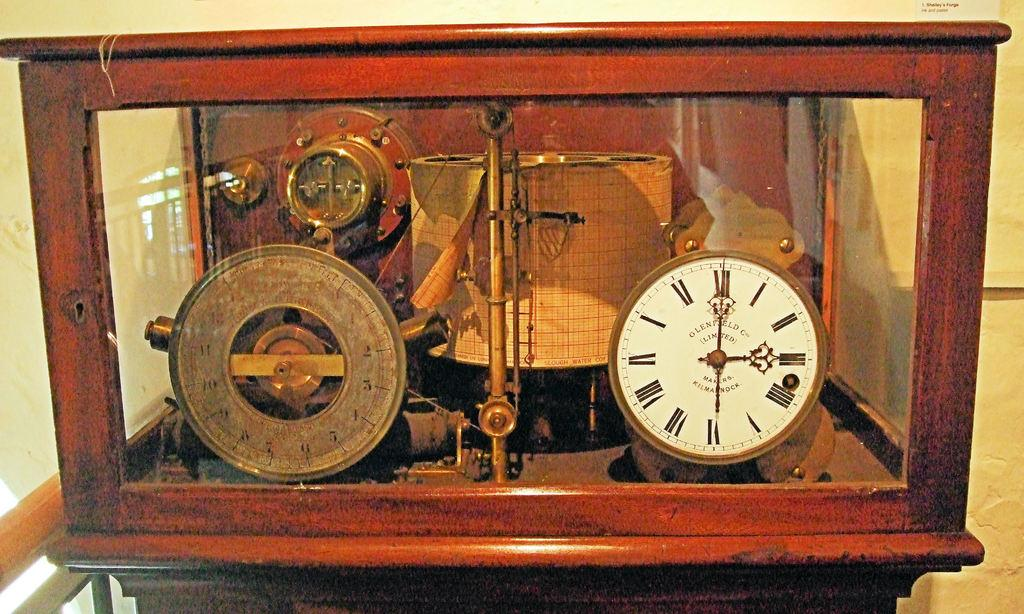<image>
Create a compact narrative representing the image presented. An old clock in a glass case has Glenfield written on the face. 